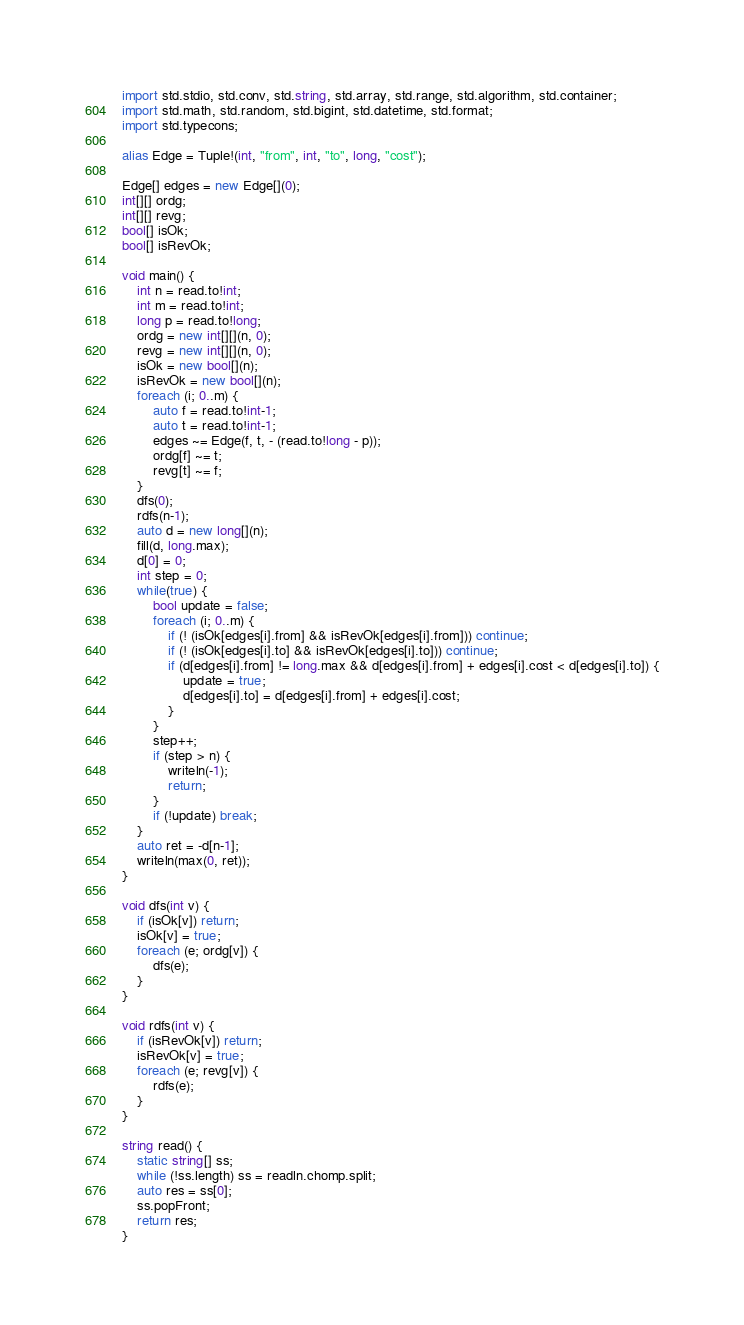<code> <loc_0><loc_0><loc_500><loc_500><_D_>import std.stdio, std.conv, std.string, std.array, std.range, std.algorithm, std.container;
import std.math, std.random, std.bigint, std.datetime, std.format;
import std.typecons;

alias Edge = Tuple!(int, "from", int, "to", long, "cost");

Edge[] edges = new Edge[](0);
int[][] ordg;
int[][] revg;
bool[] isOk;
bool[] isRevOk;

void main() {
	int n = read.to!int;
	int m = read.to!int;
	long p = read.to!long;
	ordg = new int[][](n, 0);
	revg = new int[][](n, 0);
	isOk = new bool[](n);
	isRevOk = new bool[](n);
	foreach (i; 0..m) {
		auto f = read.to!int-1;
		auto t = read.to!int-1;
		edges ~= Edge(f, t, - (read.to!long - p));
		ordg[f] ~= t;
		revg[t] ~= f;
	}
	dfs(0);
	rdfs(n-1);
	auto d = new long[](n);
	fill(d, long.max);
	d[0] = 0;
	int step = 0;
	while(true) {
		bool update = false;
		foreach (i; 0..m) {
			if (! (isOk[edges[i].from] && isRevOk[edges[i].from])) continue;
			if (! (isOk[edges[i].to] && isRevOk[edges[i].to])) continue;
			if (d[edges[i].from] != long.max && d[edges[i].from] + edges[i].cost < d[edges[i].to]) {
				update = true;
				d[edges[i].to] = d[edges[i].from] + edges[i].cost;
			}
		}
		step++;
		if (step > n) {
			writeln(-1);
			return;
		}
		if (!update) break;
	}
	auto ret = -d[n-1];
	writeln(max(0, ret));
}

void dfs(int v) {
	if (isOk[v]) return;
	isOk[v] = true;
	foreach (e; ordg[v]) {
		dfs(e);
	}
}

void rdfs(int v) {
	if (isRevOk[v]) return;
	isRevOk[v] = true;
	foreach (e; revg[v]) {
		rdfs(e);
	}
}

string read() {
	static string[] ss;
	while (!ss.length) ss = readln.chomp.split;
	auto res = ss[0];
	ss.popFront;
	return res;
}
</code> 